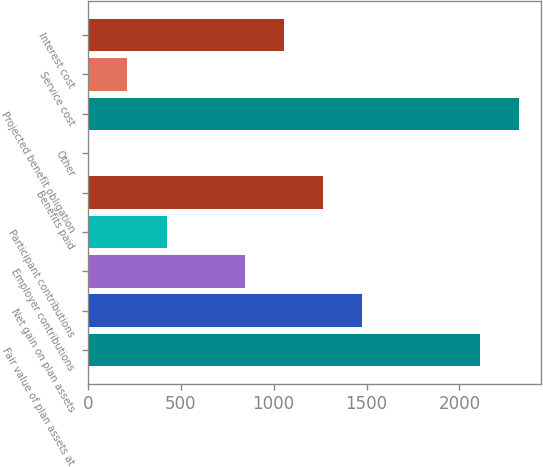Convert chart. <chart><loc_0><loc_0><loc_500><loc_500><bar_chart><fcel>Fair value of plan assets at<fcel>Net gain on plan assets<fcel>Employer contributions<fcel>Participant contributions<fcel>Benefits paid<fcel>Other<fcel>Projected benefit obligation<fcel>Service cost<fcel>Interest cost<nl><fcel>2110<fcel>1477.9<fcel>845.8<fcel>424.4<fcel>1267.2<fcel>3<fcel>2320.7<fcel>213.7<fcel>1056.5<nl></chart> 